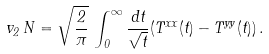<formula> <loc_0><loc_0><loc_500><loc_500>v _ { 2 } \, N = \sqrt { \frac { 2 } { \pi } } \, \int ^ { \infty } _ { 0 } \frac { d t } { \sqrt { t } } ( T ^ { x x } ( t ) - T ^ { y y } ( t ) ) \, .</formula> 